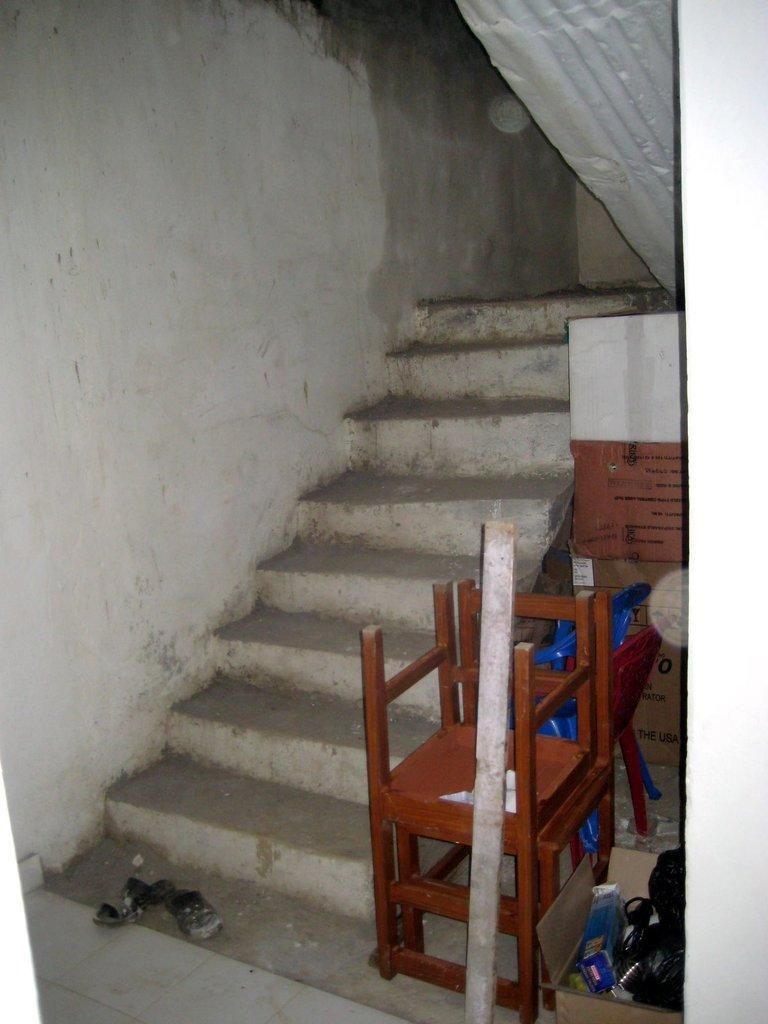What type of structure is visible in the image? There are steps in the image. What can be seen near the steps? There is footwear and chairs visible in the image. What object is used for holding or storing items in the image? There is a cardboard box with items in the image. How many blades are visible in the image? There are no blades present in the image. What type of utensil is used for stirring in the image? There is no spoon present in the image. 